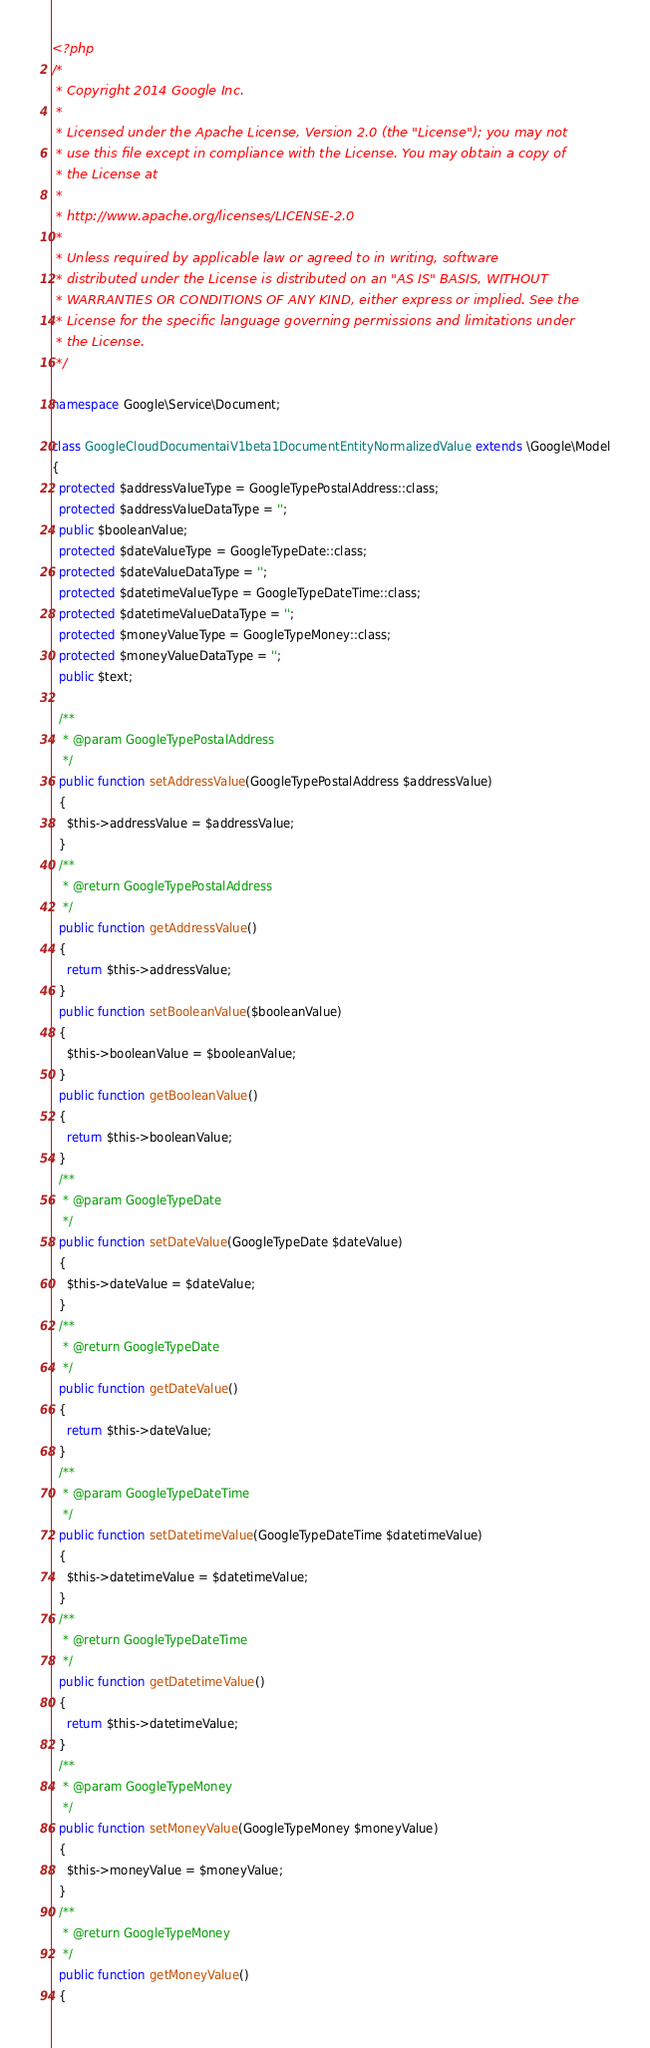<code> <loc_0><loc_0><loc_500><loc_500><_PHP_><?php
/*
 * Copyright 2014 Google Inc.
 *
 * Licensed under the Apache License, Version 2.0 (the "License"); you may not
 * use this file except in compliance with the License. You may obtain a copy of
 * the License at
 *
 * http://www.apache.org/licenses/LICENSE-2.0
 *
 * Unless required by applicable law or agreed to in writing, software
 * distributed under the License is distributed on an "AS IS" BASIS, WITHOUT
 * WARRANTIES OR CONDITIONS OF ANY KIND, either express or implied. See the
 * License for the specific language governing permissions and limitations under
 * the License.
 */

namespace Google\Service\Document;

class GoogleCloudDocumentaiV1beta1DocumentEntityNormalizedValue extends \Google\Model
{
  protected $addressValueType = GoogleTypePostalAddress::class;
  protected $addressValueDataType = '';
  public $booleanValue;
  protected $dateValueType = GoogleTypeDate::class;
  protected $dateValueDataType = '';
  protected $datetimeValueType = GoogleTypeDateTime::class;
  protected $datetimeValueDataType = '';
  protected $moneyValueType = GoogleTypeMoney::class;
  protected $moneyValueDataType = '';
  public $text;

  /**
   * @param GoogleTypePostalAddress
   */
  public function setAddressValue(GoogleTypePostalAddress $addressValue)
  {
    $this->addressValue = $addressValue;
  }
  /**
   * @return GoogleTypePostalAddress
   */
  public function getAddressValue()
  {
    return $this->addressValue;
  }
  public function setBooleanValue($booleanValue)
  {
    $this->booleanValue = $booleanValue;
  }
  public function getBooleanValue()
  {
    return $this->booleanValue;
  }
  /**
   * @param GoogleTypeDate
   */
  public function setDateValue(GoogleTypeDate $dateValue)
  {
    $this->dateValue = $dateValue;
  }
  /**
   * @return GoogleTypeDate
   */
  public function getDateValue()
  {
    return $this->dateValue;
  }
  /**
   * @param GoogleTypeDateTime
   */
  public function setDatetimeValue(GoogleTypeDateTime $datetimeValue)
  {
    $this->datetimeValue = $datetimeValue;
  }
  /**
   * @return GoogleTypeDateTime
   */
  public function getDatetimeValue()
  {
    return $this->datetimeValue;
  }
  /**
   * @param GoogleTypeMoney
   */
  public function setMoneyValue(GoogleTypeMoney $moneyValue)
  {
    $this->moneyValue = $moneyValue;
  }
  /**
   * @return GoogleTypeMoney
   */
  public function getMoneyValue()
  {</code> 